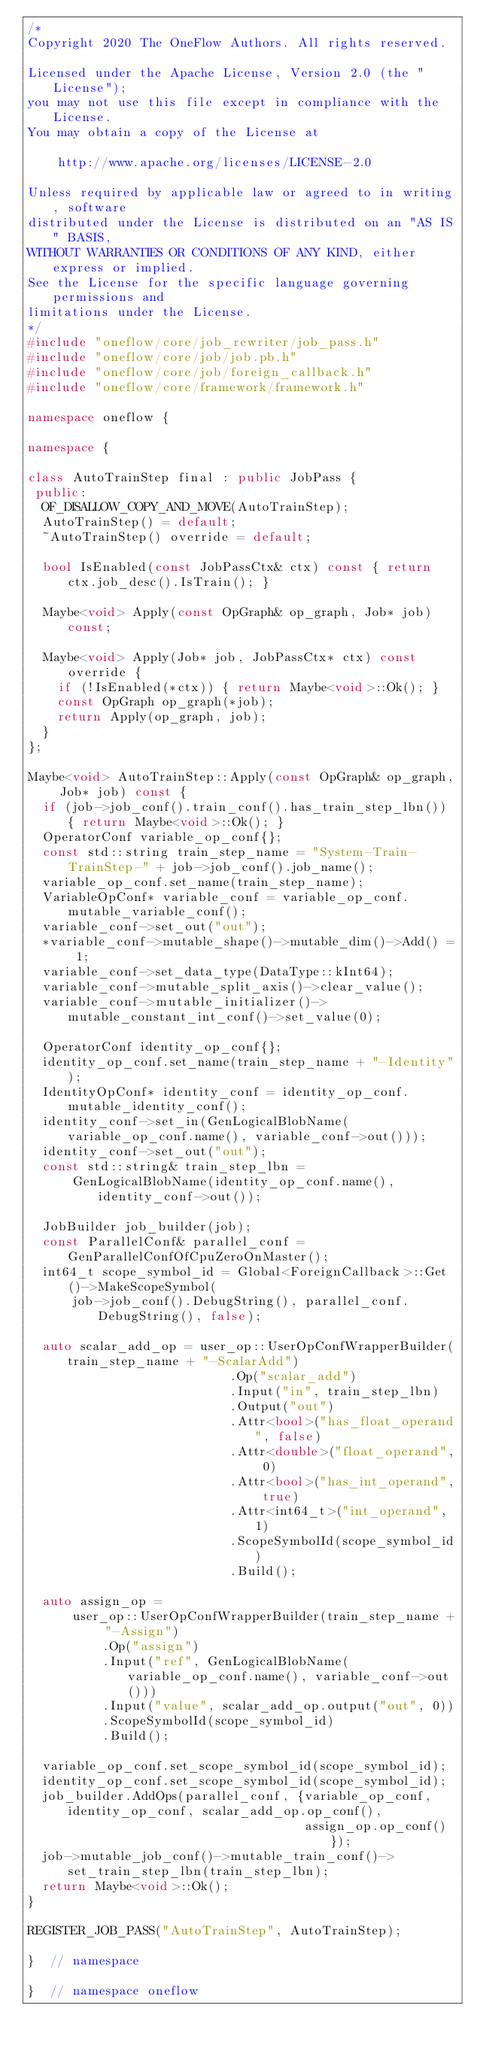Convert code to text. <code><loc_0><loc_0><loc_500><loc_500><_C++_>/*
Copyright 2020 The OneFlow Authors. All rights reserved.

Licensed under the Apache License, Version 2.0 (the "License");
you may not use this file except in compliance with the License.
You may obtain a copy of the License at

    http://www.apache.org/licenses/LICENSE-2.0

Unless required by applicable law or agreed to in writing, software
distributed under the License is distributed on an "AS IS" BASIS,
WITHOUT WARRANTIES OR CONDITIONS OF ANY KIND, either express or implied.
See the License for the specific language governing permissions and
limitations under the License.
*/
#include "oneflow/core/job_rewriter/job_pass.h"
#include "oneflow/core/job/job.pb.h"
#include "oneflow/core/job/foreign_callback.h"
#include "oneflow/core/framework/framework.h"

namespace oneflow {

namespace {

class AutoTrainStep final : public JobPass {
 public:
  OF_DISALLOW_COPY_AND_MOVE(AutoTrainStep);
  AutoTrainStep() = default;
  ~AutoTrainStep() override = default;

  bool IsEnabled(const JobPassCtx& ctx) const { return ctx.job_desc().IsTrain(); }

  Maybe<void> Apply(const OpGraph& op_graph, Job* job) const;

  Maybe<void> Apply(Job* job, JobPassCtx* ctx) const override {
    if (!IsEnabled(*ctx)) { return Maybe<void>::Ok(); }
    const OpGraph op_graph(*job);
    return Apply(op_graph, job);
  }
};

Maybe<void> AutoTrainStep::Apply(const OpGraph& op_graph, Job* job) const {
  if (job->job_conf().train_conf().has_train_step_lbn()) { return Maybe<void>::Ok(); }
  OperatorConf variable_op_conf{};
  const std::string train_step_name = "System-Train-TrainStep-" + job->job_conf().job_name();
  variable_op_conf.set_name(train_step_name);
  VariableOpConf* variable_conf = variable_op_conf.mutable_variable_conf();
  variable_conf->set_out("out");
  *variable_conf->mutable_shape()->mutable_dim()->Add() = 1;
  variable_conf->set_data_type(DataType::kInt64);
  variable_conf->mutable_split_axis()->clear_value();
  variable_conf->mutable_initializer()->mutable_constant_int_conf()->set_value(0);

  OperatorConf identity_op_conf{};
  identity_op_conf.set_name(train_step_name + "-Identity");
  IdentityOpConf* identity_conf = identity_op_conf.mutable_identity_conf();
  identity_conf->set_in(GenLogicalBlobName(variable_op_conf.name(), variable_conf->out()));
  identity_conf->set_out("out");
  const std::string& train_step_lbn =
      GenLogicalBlobName(identity_op_conf.name(), identity_conf->out());

  JobBuilder job_builder(job);
  const ParallelConf& parallel_conf = GenParallelConfOfCpuZeroOnMaster();
  int64_t scope_symbol_id = Global<ForeignCallback>::Get()->MakeScopeSymbol(
      job->job_conf().DebugString(), parallel_conf.DebugString(), false);

  auto scalar_add_op = user_op::UserOpConfWrapperBuilder(train_step_name + "-ScalarAdd")
                           .Op("scalar_add")
                           .Input("in", train_step_lbn)
                           .Output("out")
                           .Attr<bool>("has_float_operand", false)
                           .Attr<double>("float_operand", 0)
                           .Attr<bool>("has_int_operand", true)
                           .Attr<int64_t>("int_operand", 1)
                           .ScopeSymbolId(scope_symbol_id)
                           .Build();

  auto assign_op =
      user_op::UserOpConfWrapperBuilder(train_step_name + "-Assign")
          .Op("assign")
          .Input("ref", GenLogicalBlobName(variable_op_conf.name(), variable_conf->out()))
          .Input("value", scalar_add_op.output("out", 0))
          .ScopeSymbolId(scope_symbol_id)
          .Build();

  variable_op_conf.set_scope_symbol_id(scope_symbol_id);
  identity_op_conf.set_scope_symbol_id(scope_symbol_id);
  job_builder.AddOps(parallel_conf, {variable_op_conf, identity_op_conf, scalar_add_op.op_conf(),
                                     assign_op.op_conf()});
  job->mutable_job_conf()->mutable_train_conf()->set_train_step_lbn(train_step_lbn);
  return Maybe<void>::Ok();
}

REGISTER_JOB_PASS("AutoTrainStep", AutoTrainStep);

}  // namespace

}  // namespace oneflow
</code> 